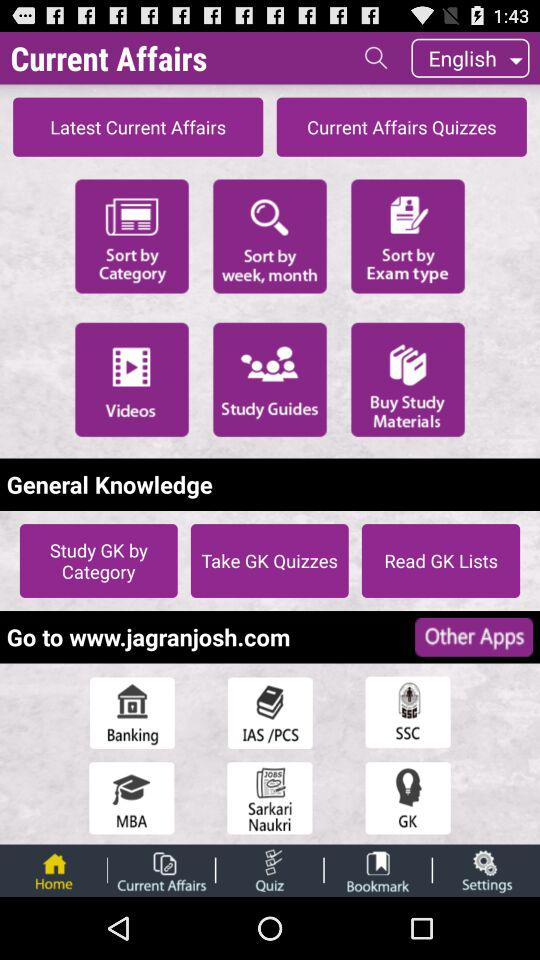What is the app name? The app name is "Current Affairs". 